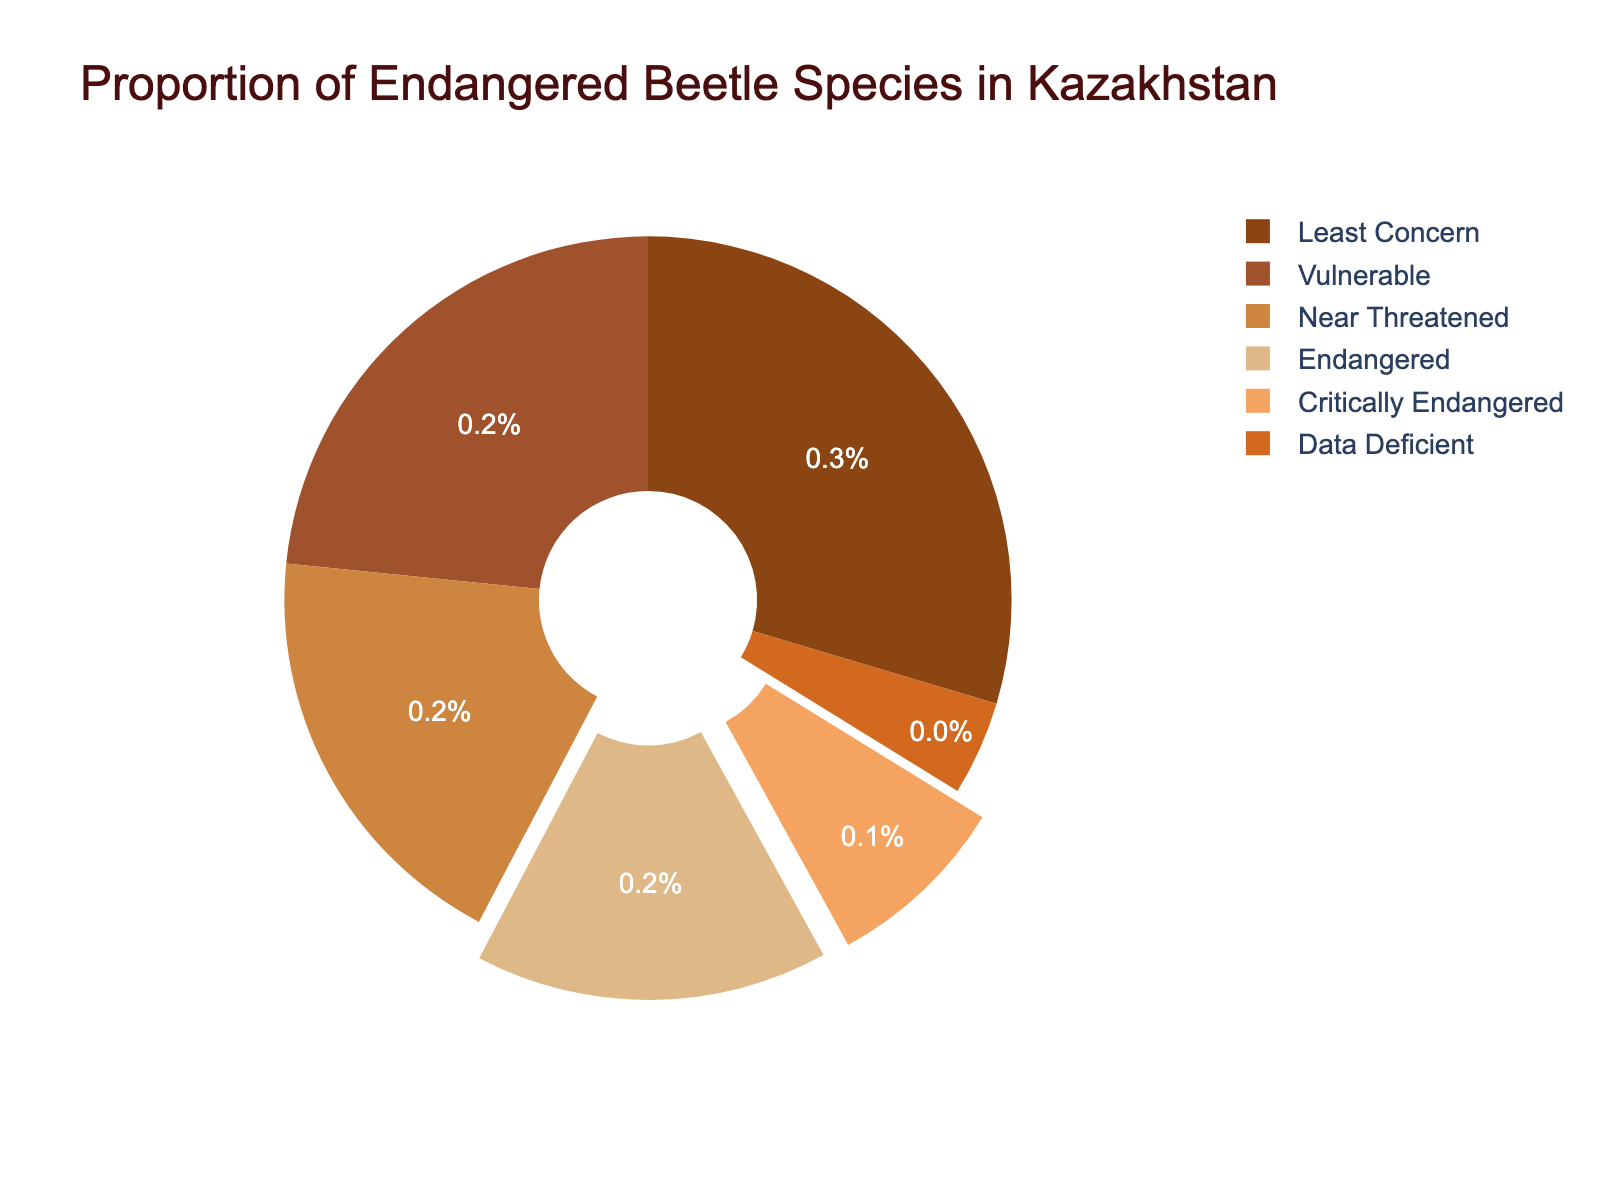Which category has the highest percentage of endangered beetle species? Look for the category with the largest slice in the pie chart. The 'Least Concern' category has the largest chunk with 29.6%.
Answer: Least Concern What is the total percentage of beetle species in the 'Endangered' and 'Critically Endangered' categories combined? Add the percentages for 'Endangered' (15.7%) and 'Critically Endangered' (8.2%). So, 15.7 + 8.2 = 23.9%.
Answer: 23.9% Which category has a higher percentage, 'Vulnerable' or 'Near Threatened'? Compare the percentages for 'Vulnerable' (23.4%) and 'Near Threatened' (18.9%). Since 23.4% > 18.9%, 'Vulnerable' has a higher percentage.
Answer: Vulnerable What is the difference in percentage between 'Least Concern' and 'Data Deficient'? Subtract the percentage of 'Data Deficient' (4.2%) from 'Least Concern' (29.6%). So, 29.6 - 4.2 = 25.4%.
Answer: 25.4% How much more percentage does 'Vulnerable' have compared to 'Critically Endangered'? Subtract the percentage of 'Critically Endangered' (8.2%) from 'Vulnerable' (23.4%). So, 23.4 - 8.2 = 15.2%.
Answer: 15.2% Is the percentage of 'Near Threatened' greater than the sum of 'Critically Endangered' and 'Data Deficient'? Calculate the sum of 'Critically Endangered' (8.2%) and 'Data Deficient' (4.2%), which gives 12.4%. Compare it with 'Near Threatened' (18.9%). Since 18.9% > 12.4%, 'Near Threatened' is greater.
Answer: Yes If you were to reclassify 'Critically Endangered' and 'Endangered' into a single category, what percentage would this new category represent? Add the percentages of 'Critically Endangered' (8.2%) and 'Endangered' (15.7%), which gives 8.2 + 15.7 = 23.9%.
Answer: 23.9% Which category slice is second-largest in the pie chart? Look for the category with the second-largest slice after 'Least Concern' (29.6%). The 'Vulnerable' category with 23.4% is the next largest.
Answer: Vulnerable What is the combined percentage of 'Near Threatened', 'Endangered', and 'Vulnerable'? Add the percentages of 'Near Threatened' (18.9%), 'Endangered' (15.7%), and 'Vulnerable' (23.4%). So, 18.9 + 15.7 + 23.4 = 58%.
Answer: 58% What visual indication highlights the 'Critically Endangered' and 'Endangered' categories? Observe any special visual attributes like pulling out or highlighting. The 'Critically Endangered' and 'Endangered' slices are slightly pulled out from the center of the pie chart.
Answer: Pulled out from the center 